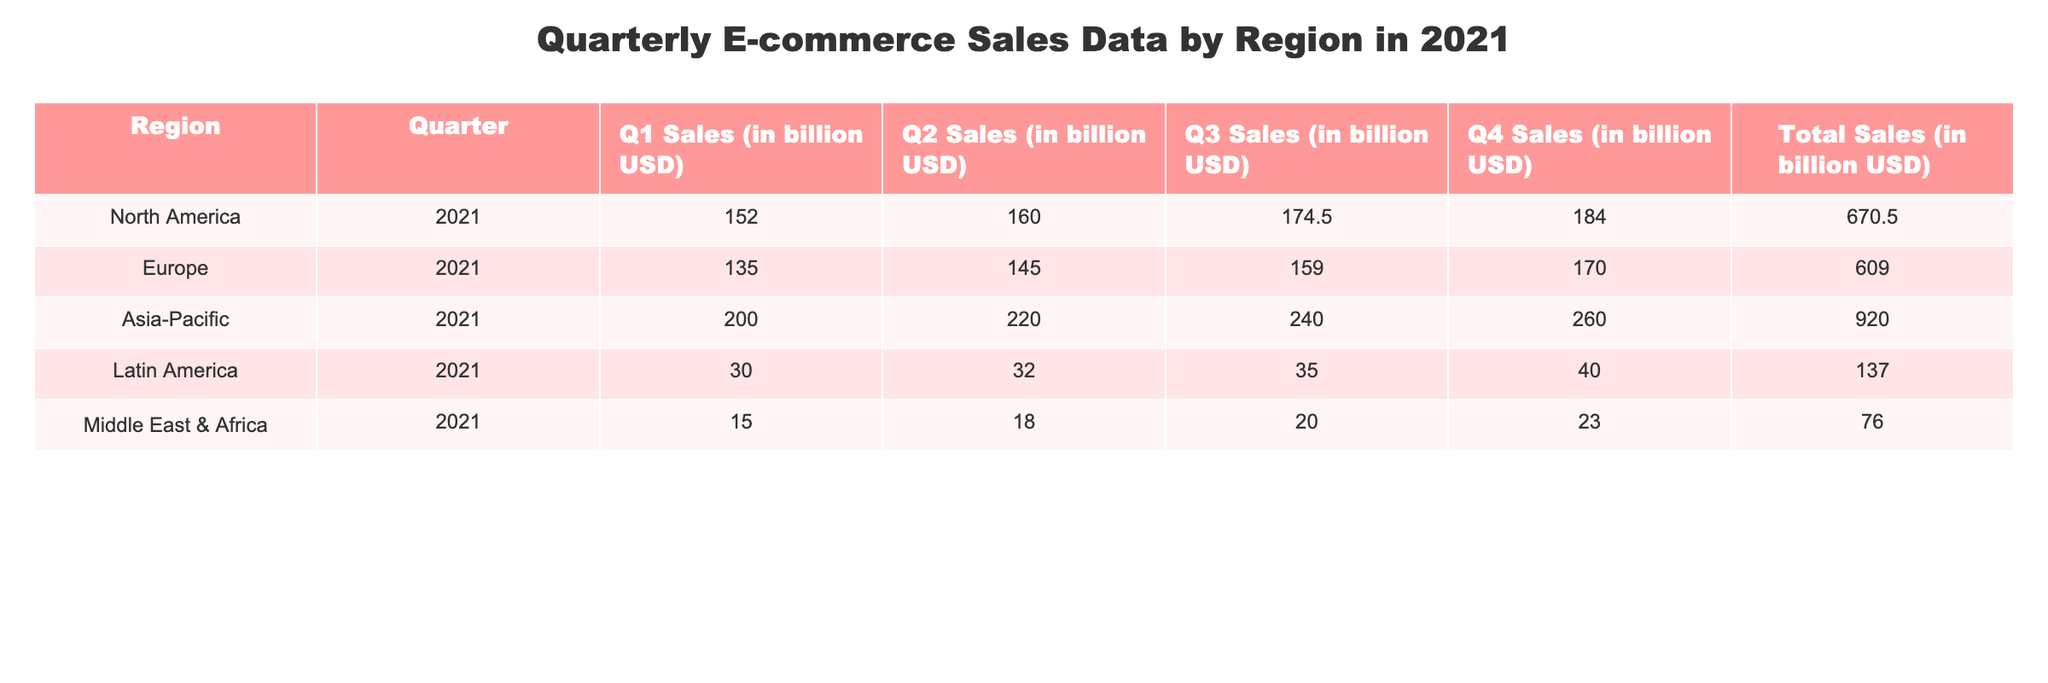What region had the highest total e-commerce sales in 2021? By looking at the "Total Sales" column, we can see that the Asia-Pacific region has the highest total sales value at 920.0 billion USD.
Answer: Asia-Pacific Which quarter had the lowest sales across all regions? We can find the minimum sales value in each quarter by checking each quarterly sales column. The minimum is 15.0 billion USD in Q1 for the Middle East & Africa region.
Answer: 15.0 billion USD in Q1 What was the total sales for North America in 2021? The total sales figure for North America can be found in the "Total Sales" column for that region. It is reported as 670.5 billion USD.
Answer: 670.5 billion USD What were the total e-commerce sales for Europe and Latin America combined in 2021? We add the "Total Sales" of Europe (609.0 billion USD) and Latin America (137.0 billion USD), which gives us 609.0 + 137.0 = 746.0 billion USD.
Answer: 746.0 billion USD Did any region surpass 200 billion USD in Q1 sales? We examine the Q1 sales figures and see that the only region exceeding 200 billion USD is Asia-Pacific with 200.0 billion USD.
Answer: No Which region had the highest sales in Q4, and what was the value? By looking at the Q4 sales column, we can see that Asia-Pacific led with 260.0 billion USD in sales for Q4.
Answer: Asia-Pacific, 260.0 billion USD What is the average quarterly sales for the Middle East & Africa in 2021? We calculate the average of the four quarterly sales figures: (15.0 + 18.0 + 20.0 + 23.0) / 4 = 19.0 billion USD.
Answer: 19.0 billion USD Which region had the greatest sales growth from Q1 to Q4? We find the difference between Q1 and Q4 for all regions. Asia-Pacific shows an increase of 60.0 billion USD (from 200.0 to 260.0), which is the greatest growth.
Answer: Asia-Pacific What was the combined sales figure for Q2 across all regions? We add up the Q2 sales: 160.0 (North America) + 145.0 (Europe) + 220.0 (Asia-Pacific) + 32.0 (Latin America) + 18.0 (Middle East & Africa) = 575.0 billion USD.
Answer: 575.0 billion USD Is the total sales of Latin America more than the combined sales of Middle East & Africa in 2021? Latin America total sales is 137.0 billion USD, while Middle East & Africa total sales is 76.0 billion USD. Since 137.0 > (76.0), the statement is true.
Answer: Yes 